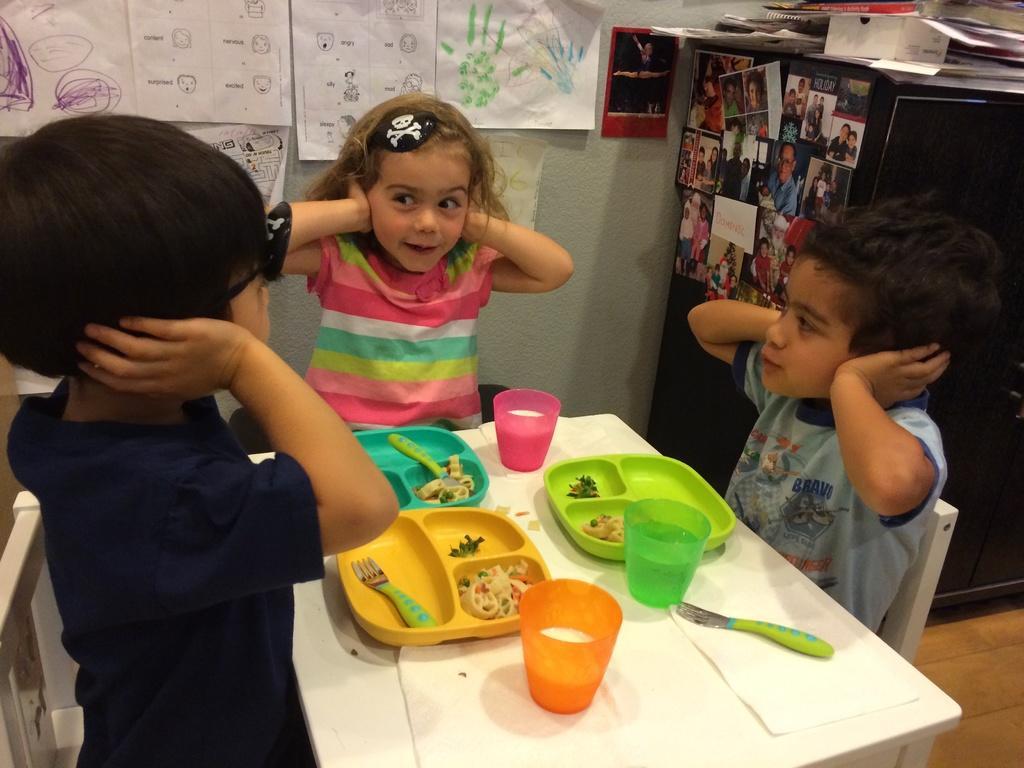How would you summarize this image in a sentence or two? In this picture, there is a table at the bottom. Around the table, there are kids sitting on the chairs. In the center, there is a girl wearing a striped shirt. Towards the right, there is a boy wearing grey shirt. Towards the left, there is a kid wearing blue t shirt. On the table, there are plates with food and glasses with liquids. On the top, there is a wall with charts and papers. Towards the right corner, there is a desk with pictures. 